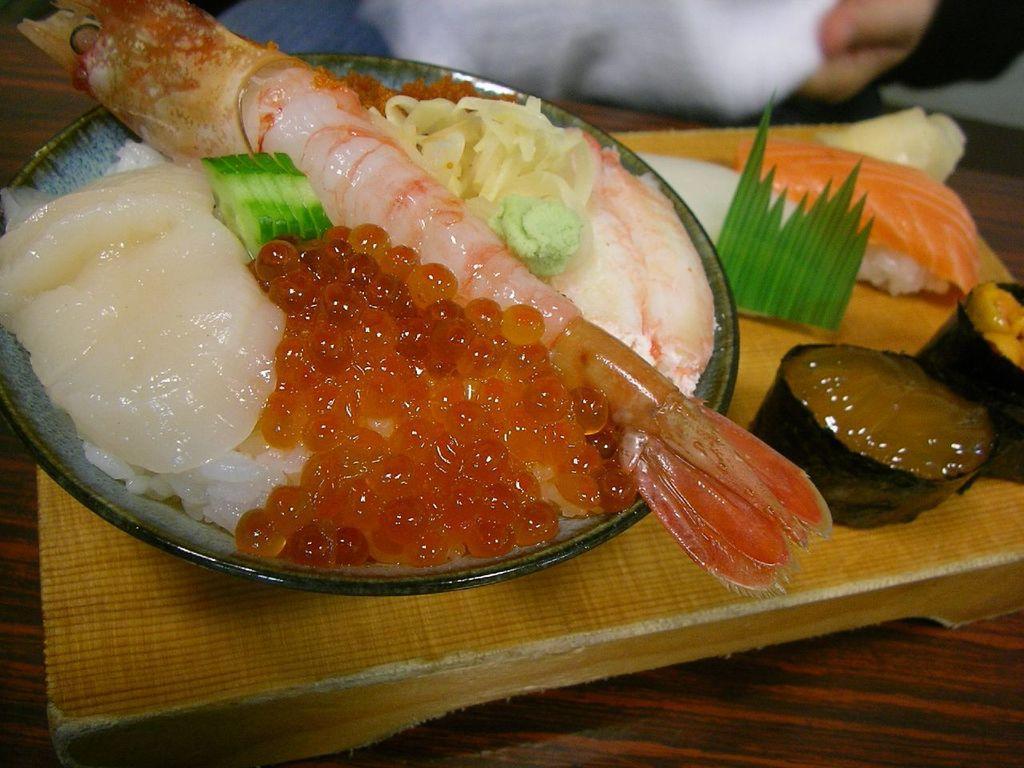In one or two sentences, can you explain what this image depicts? In this picture we can see a plateful of seafood placed on a wooden table. 